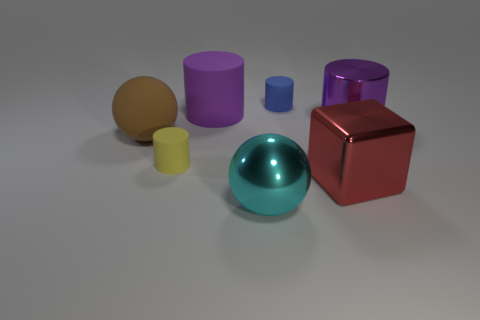Subtract all brown cylinders. Subtract all brown cubes. How many cylinders are left? 4 Add 1 small blue matte objects. How many objects exist? 8 Subtract all cylinders. How many objects are left? 3 Subtract all green rubber spheres. Subtract all large purple matte objects. How many objects are left? 6 Add 5 big purple shiny things. How many big purple shiny things are left? 6 Add 4 tiny red things. How many tiny red things exist? 4 Subtract 0 cyan cylinders. How many objects are left? 7 